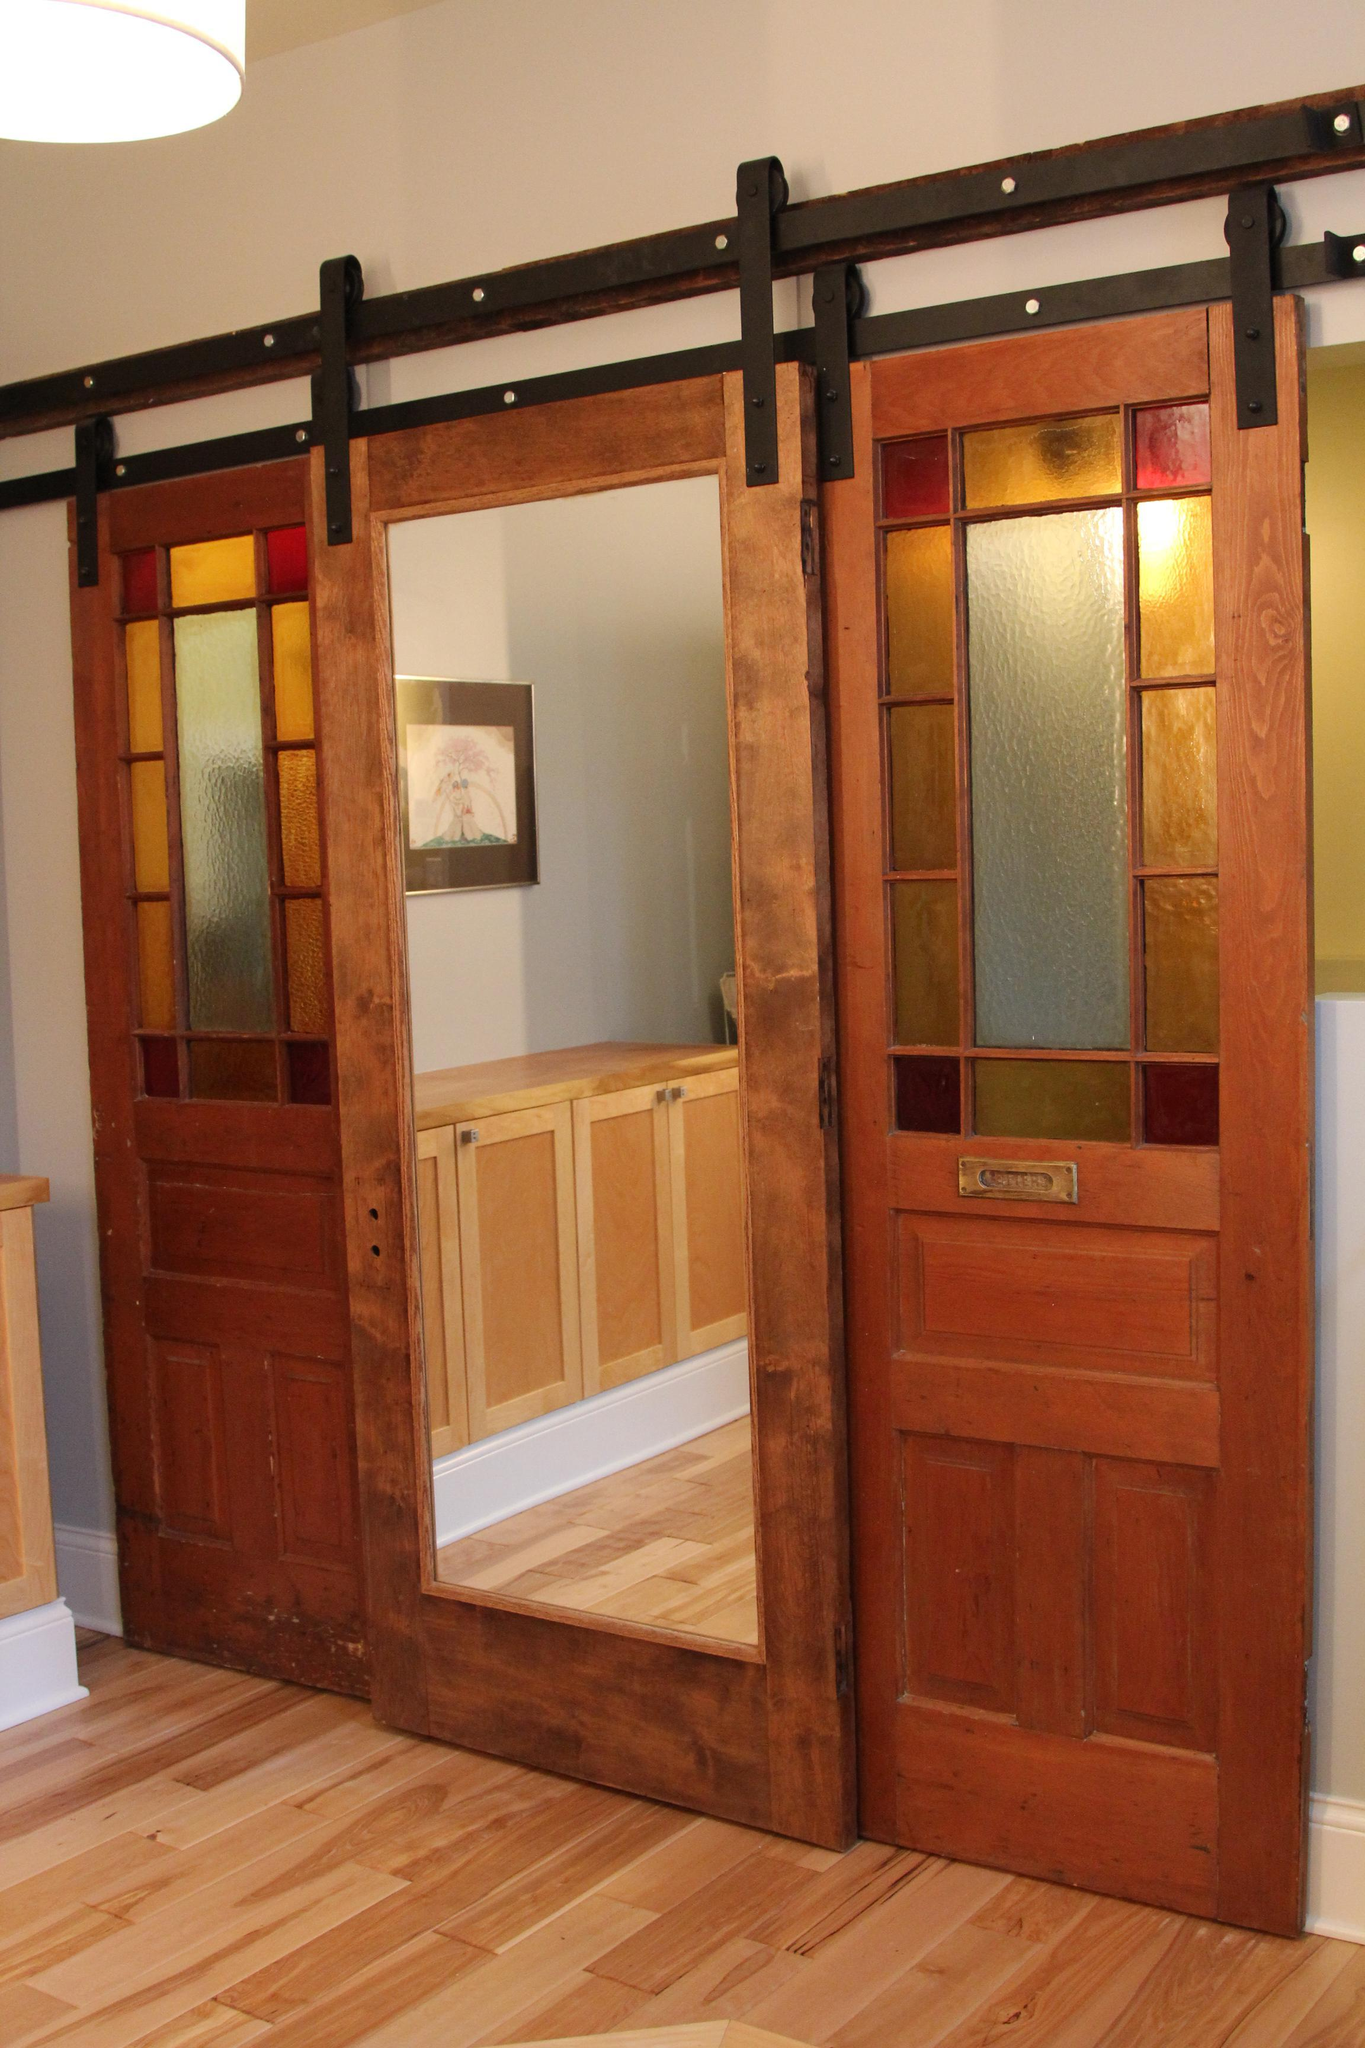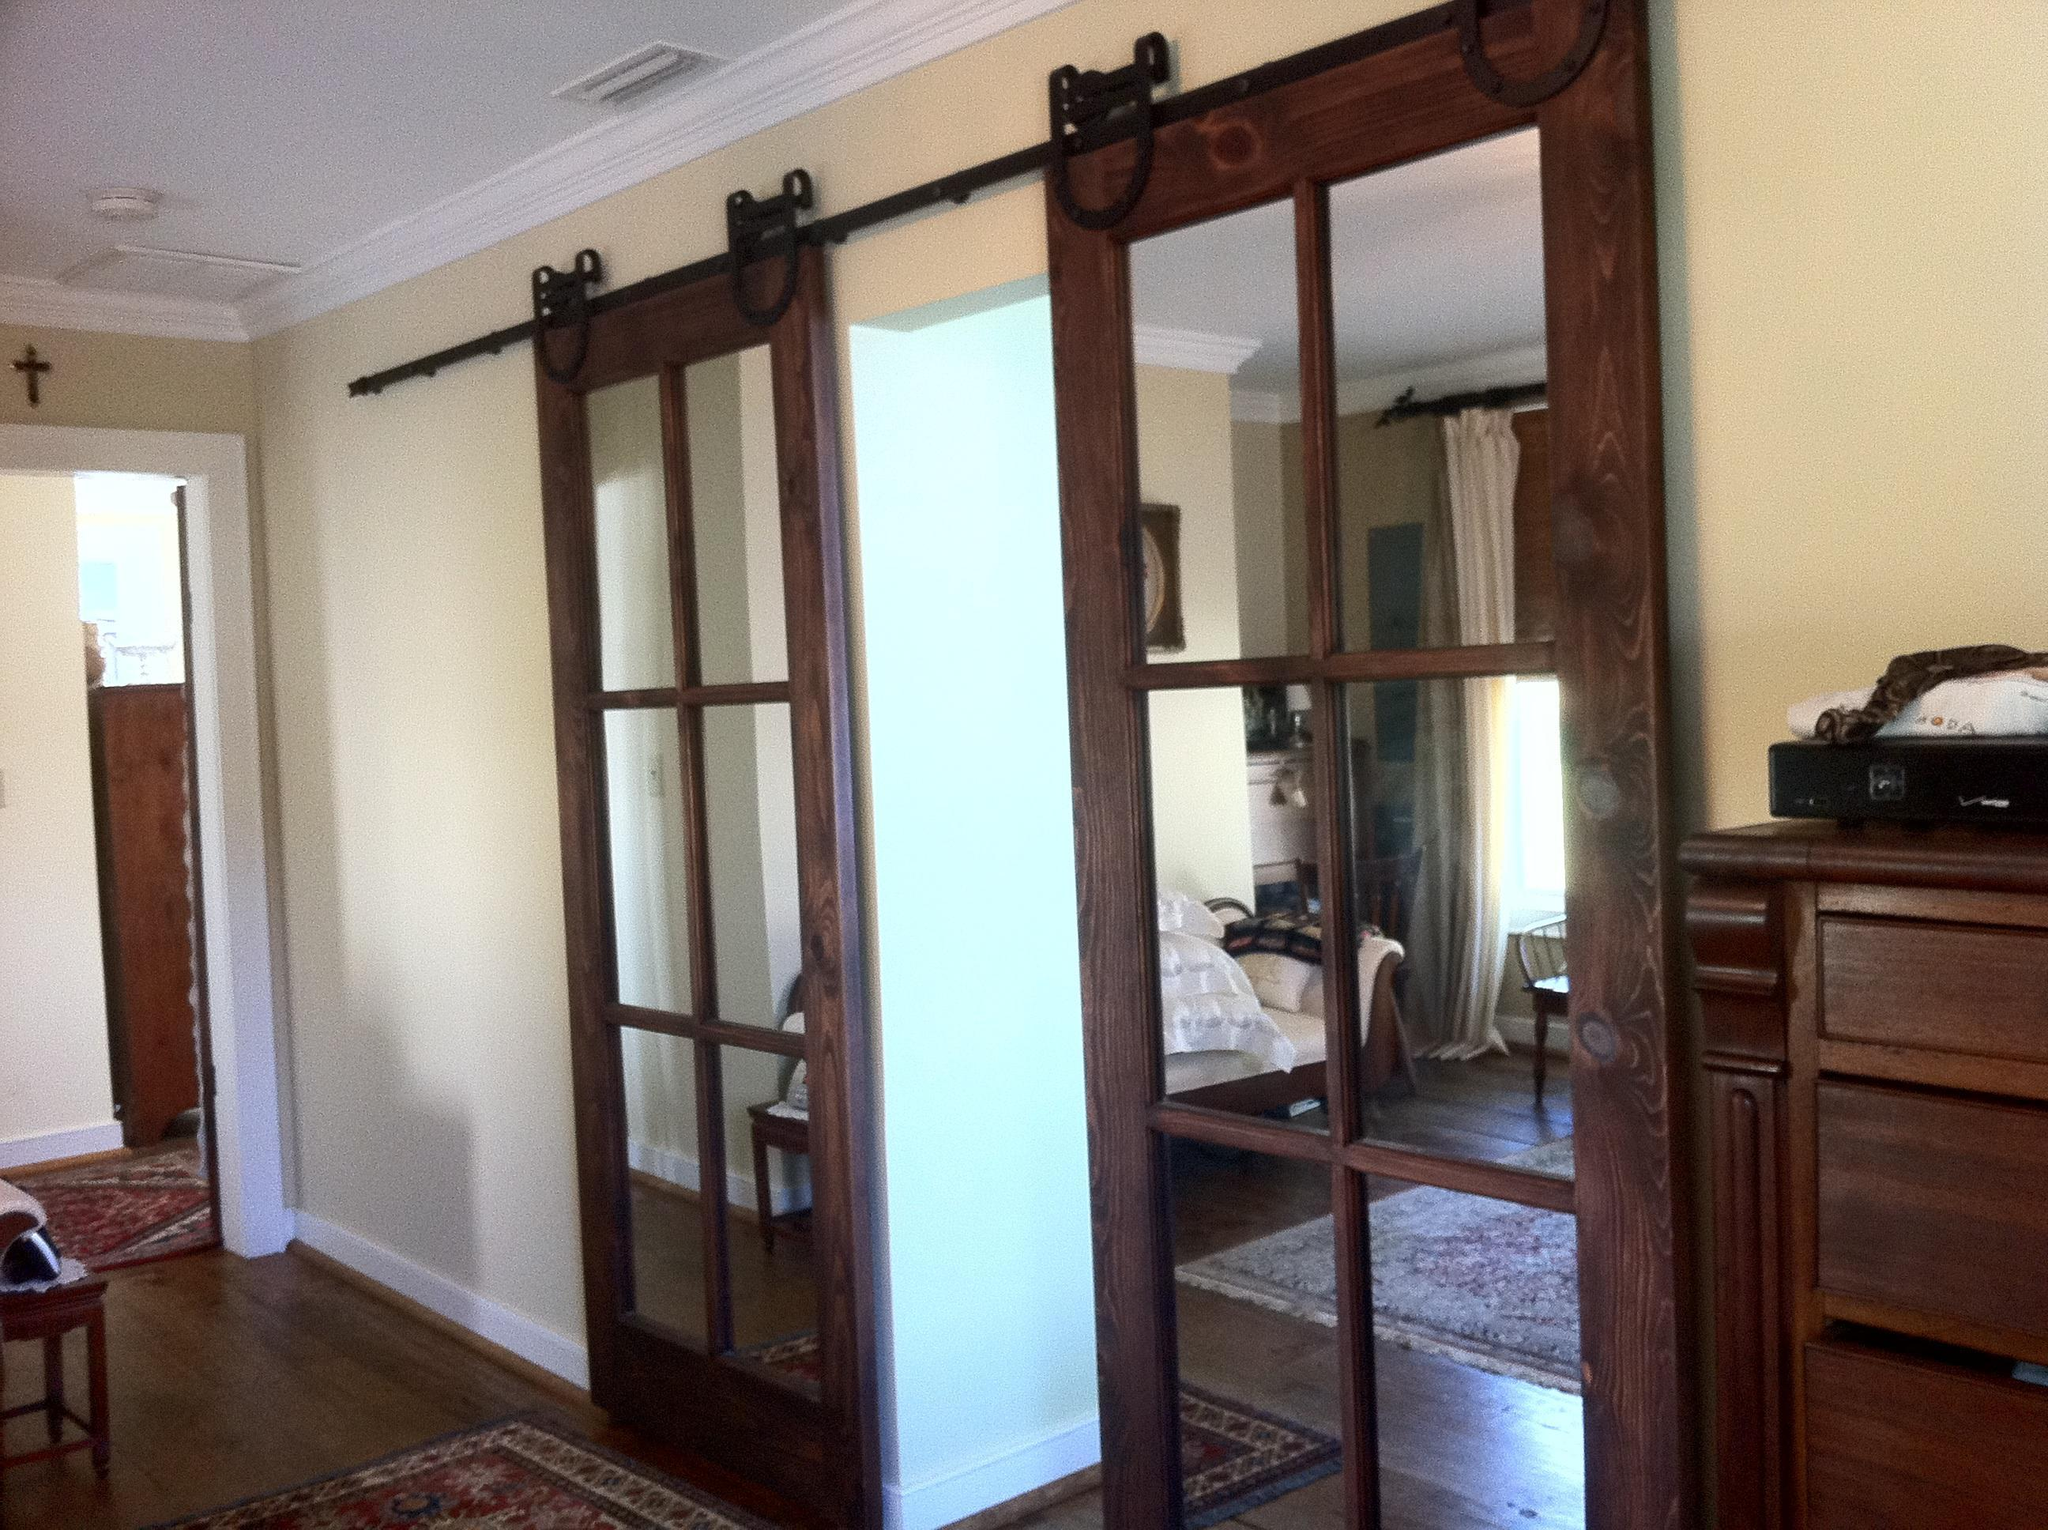The first image is the image on the left, the second image is the image on the right. For the images displayed, is the sentence "There are three hanging doors." factually correct? Answer yes or no. No. 